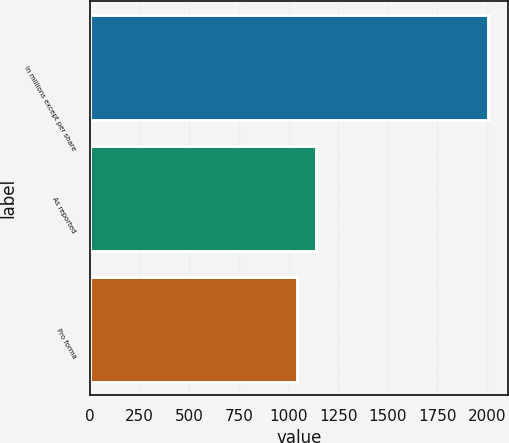Convert chart. <chart><loc_0><loc_0><loc_500><loc_500><bar_chart><fcel>In millions except per share<fcel>As reported<fcel>Pro forma<nl><fcel>2005<fcel>1139.2<fcel>1043<nl></chart> 